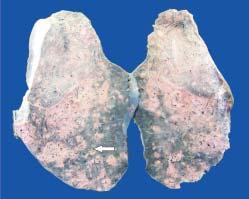does the sectioned surface of the lung parenchyma show presence of minute millet-seed sized tubercles?
Answer the question using a single word or phrase. Yes 